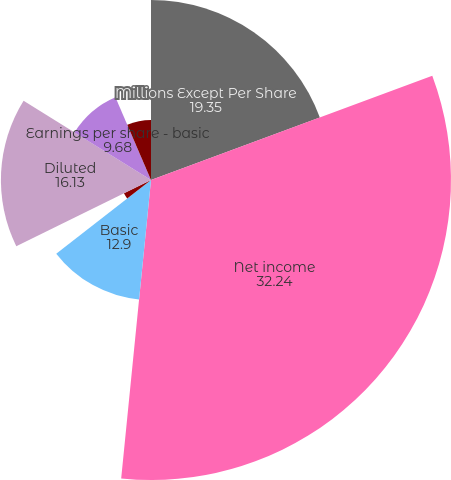Convert chart. <chart><loc_0><loc_0><loc_500><loc_500><pie_chart><fcel>Millions Except Per Share<fcel>Net income<fcel>Basic<fcel>Dilutive effect of stock<fcel>Dilutive effect of retention<fcel>Diluted<fcel>Earnings per share - basic<fcel>Earnings per share - diluted<nl><fcel>19.35%<fcel>32.24%<fcel>12.9%<fcel>3.24%<fcel>0.01%<fcel>16.13%<fcel>9.68%<fcel>6.46%<nl></chart> 